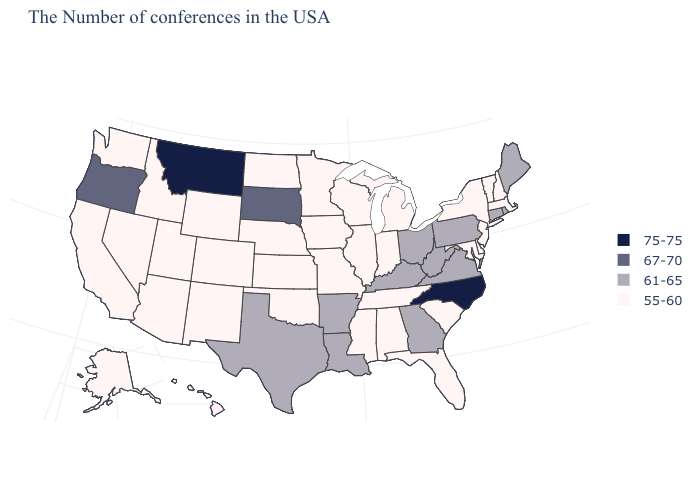Does North Carolina have the lowest value in the USA?
Quick response, please. No. Name the states that have a value in the range 55-60?
Be succinct. Massachusetts, New Hampshire, Vermont, New York, New Jersey, Delaware, Maryland, South Carolina, Florida, Michigan, Indiana, Alabama, Tennessee, Wisconsin, Illinois, Mississippi, Missouri, Minnesota, Iowa, Kansas, Nebraska, Oklahoma, North Dakota, Wyoming, Colorado, New Mexico, Utah, Arizona, Idaho, Nevada, California, Washington, Alaska, Hawaii. Among the states that border Rhode Island , does Massachusetts have the highest value?
Concise answer only. No. Among the states that border Utah , which have the lowest value?
Keep it brief. Wyoming, Colorado, New Mexico, Arizona, Idaho, Nevada. Name the states that have a value in the range 55-60?
Write a very short answer. Massachusetts, New Hampshire, Vermont, New York, New Jersey, Delaware, Maryland, South Carolina, Florida, Michigan, Indiana, Alabama, Tennessee, Wisconsin, Illinois, Mississippi, Missouri, Minnesota, Iowa, Kansas, Nebraska, Oklahoma, North Dakota, Wyoming, Colorado, New Mexico, Utah, Arizona, Idaho, Nevada, California, Washington, Alaska, Hawaii. Does Montana have the highest value in the USA?
Concise answer only. Yes. Does Alabama have the highest value in the USA?
Short answer required. No. Name the states that have a value in the range 61-65?
Answer briefly. Maine, Rhode Island, Connecticut, Pennsylvania, Virginia, West Virginia, Ohio, Georgia, Kentucky, Louisiana, Arkansas, Texas. What is the value of South Carolina?
Give a very brief answer. 55-60. Does the first symbol in the legend represent the smallest category?
Write a very short answer. No. Which states hav the highest value in the West?
Give a very brief answer. Montana. Does Hawaii have the lowest value in the USA?
Concise answer only. Yes. Does Alaska have the same value as Texas?
Be succinct. No. What is the value of Arizona?
Keep it brief. 55-60. What is the value of Texas?
Be succinct. 61-65. 